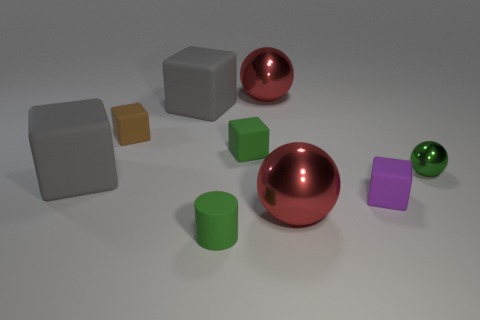Subtract all blue cylinders. How many red spheres are left? 2 Subtract all purple cubes. How many cubes are left? 4 Subtract all small cubes. How many cubes are left? 2 Add 1 small matte objects. How many objects exist? 10 Subtract all blue cubes. Subtract all blue spheres. How many cubes are left? 5 Subtract all cylinders. How many objects are left? 8 Subtract all large brown objects. Subtract all gray rubber things. How many objects are left? 7 Add 4 purple rubber cubes. How many purple rubber cubes are left? 5 Add 5 brown cylinders. How many brown cylinders exist? 5 Subtract 1 green spheres. How many objects are left? 8 